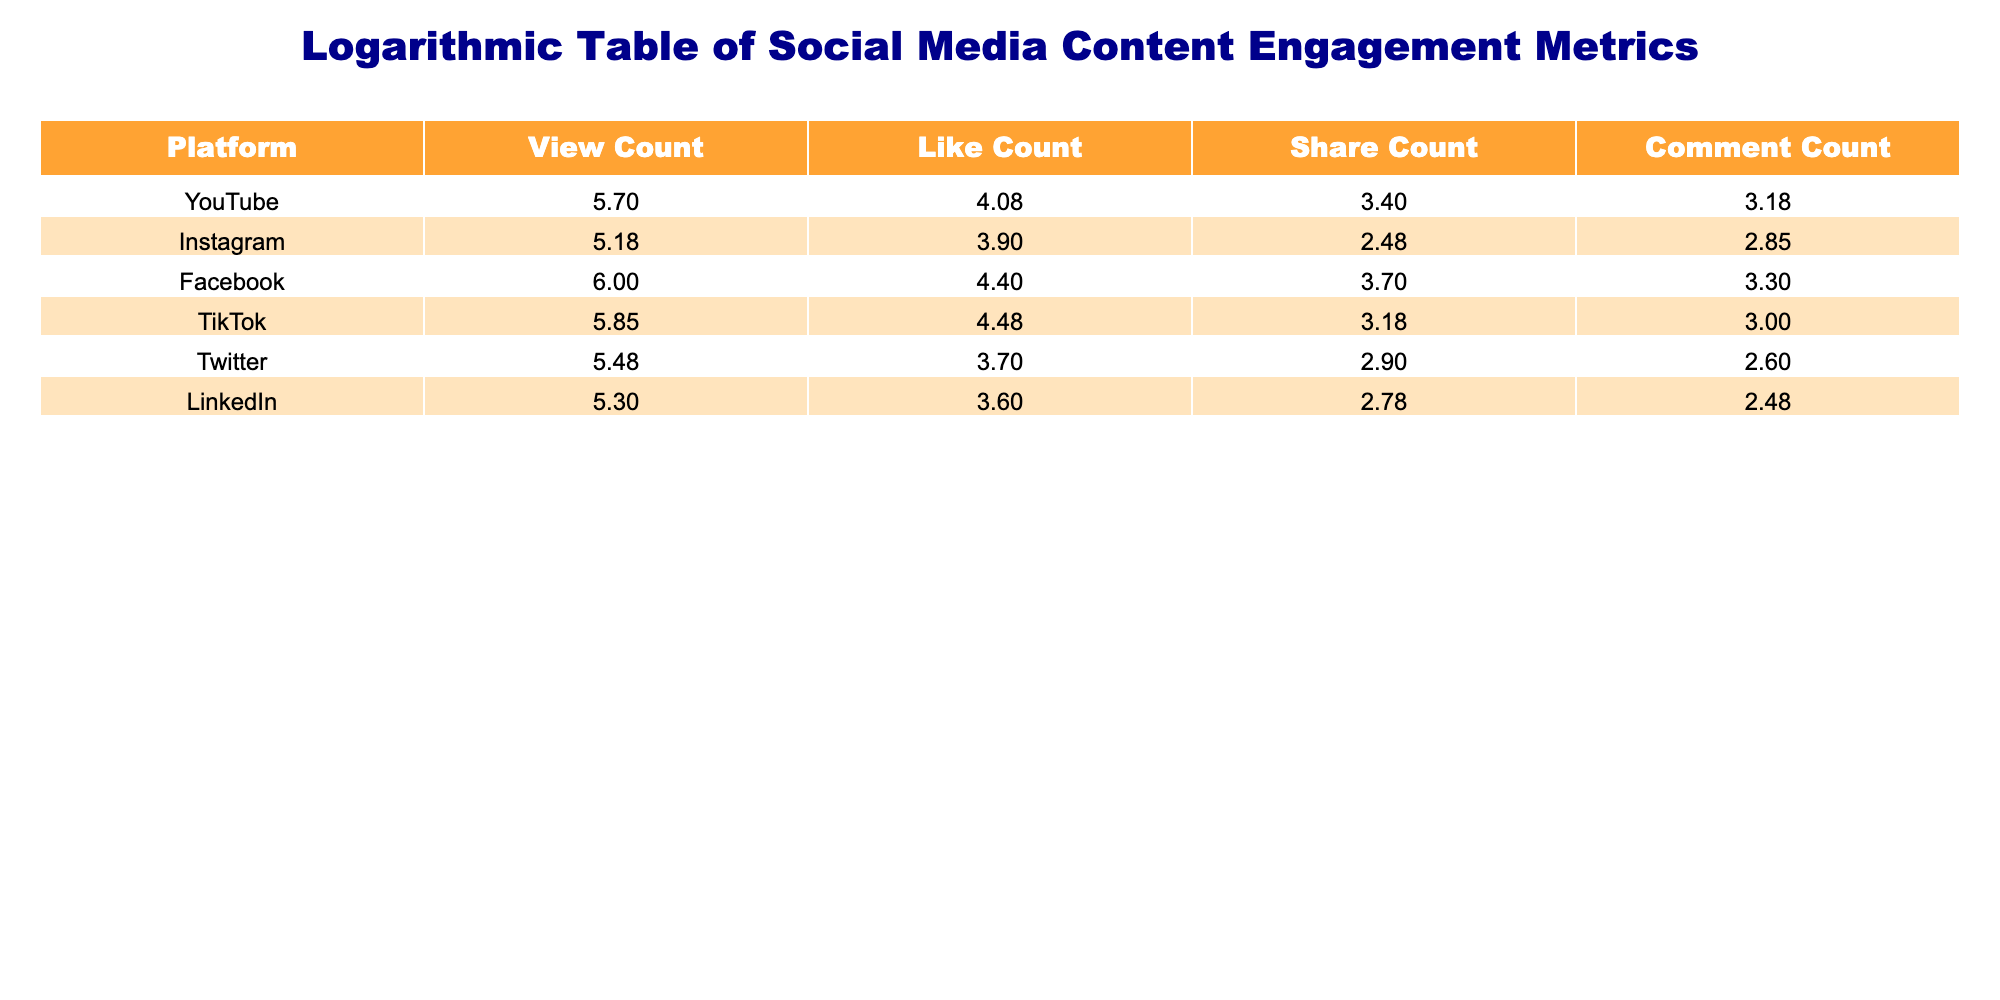What is the logarithmic view count for TikTok? Referring to the table, the view count for TikTok is provided directly under the "View Count" column after applying the logarithmic transformation. The value is approximately 5.845.
Answer: 5.845 Which platform has the highest logarithmic like count? The table lists the like counts, and we can compare them directly under the "Like Count" column. TikTok has the highest value of approximately 4.477.
Answer: 4.477 What is the total of the logarithmic share counts for all platforms? To find the total share count, I will sum the logarithmic values listed in the "Share Count" column: 3.398 (YouTube) + 2.477 (Instagram) + 3.699 (Facebook) + 3.176 (TikTok) + 2.903 (Twitter) + 2.477 (LinkedIn) = 18.110.
Answer: 18.110 Is the logarithmic like count for YouTube greater than that for Facebook? Comparing the values directly from the table, the logarithmic like count for YouTube is approximately 4.079, while for Facebook, it is about 4.398. Thus, the statement is false.
Answer: False Which platform has a logarithmic comment count that is less than 3? Examining the "Comment Count" column, the logarithmic values are 3.176 (YouTube), 2.845 (Instagram), 3.301 (Facebook), 3.000 (TikTok), 2.602 (Twitter), and 2.477 (LinkedIn). Only TikTok and LinkedIn have values under 3.
Answer: TikTok, LinkedIn What is the average logarithmic view count across all platforms? To calculate the average, I will sum the logarithmic view counts: 5.699 (YouTube) + 5.176 (Instagram) + 6.000 (Facebook) + 5.845 (TikTok) + 5.477 (Twitter) + 5.301 (LinkedIn) = 33.678. Then divide by the number of platforms (6): 33.678 / 6 = 5.613.
Answer: 5.613 Is the logarithmic like count for Instagram higher than the logarithmic comment count for Twitter? From the table, Instagram's logarithmic like count is approximately 3.903, and Twitter's logarithmic comment count is about 2.602. Since 3.903 is indeed higher than 2.602, the statement is true.
Answer: True What is the difference between the highest and lowest logarithmic view count? The highest logarithmic view count is for Facebook at approximately 6.000, and the lowest is for Instagram at approximately 5.176. The difference is calculated as 6.000 - 5.176 = 0.824.
Answer: 0.824 